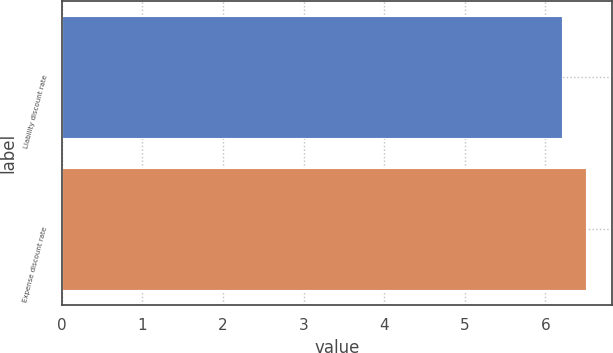Convert chart. <chart><loc_0><loc_0><loc_500><loc_500><bar_chart><fcel>Liability discount rate<fcel>Expense discount rate<nl><fcel>6.2<fcel>6.5<nl></chart> 